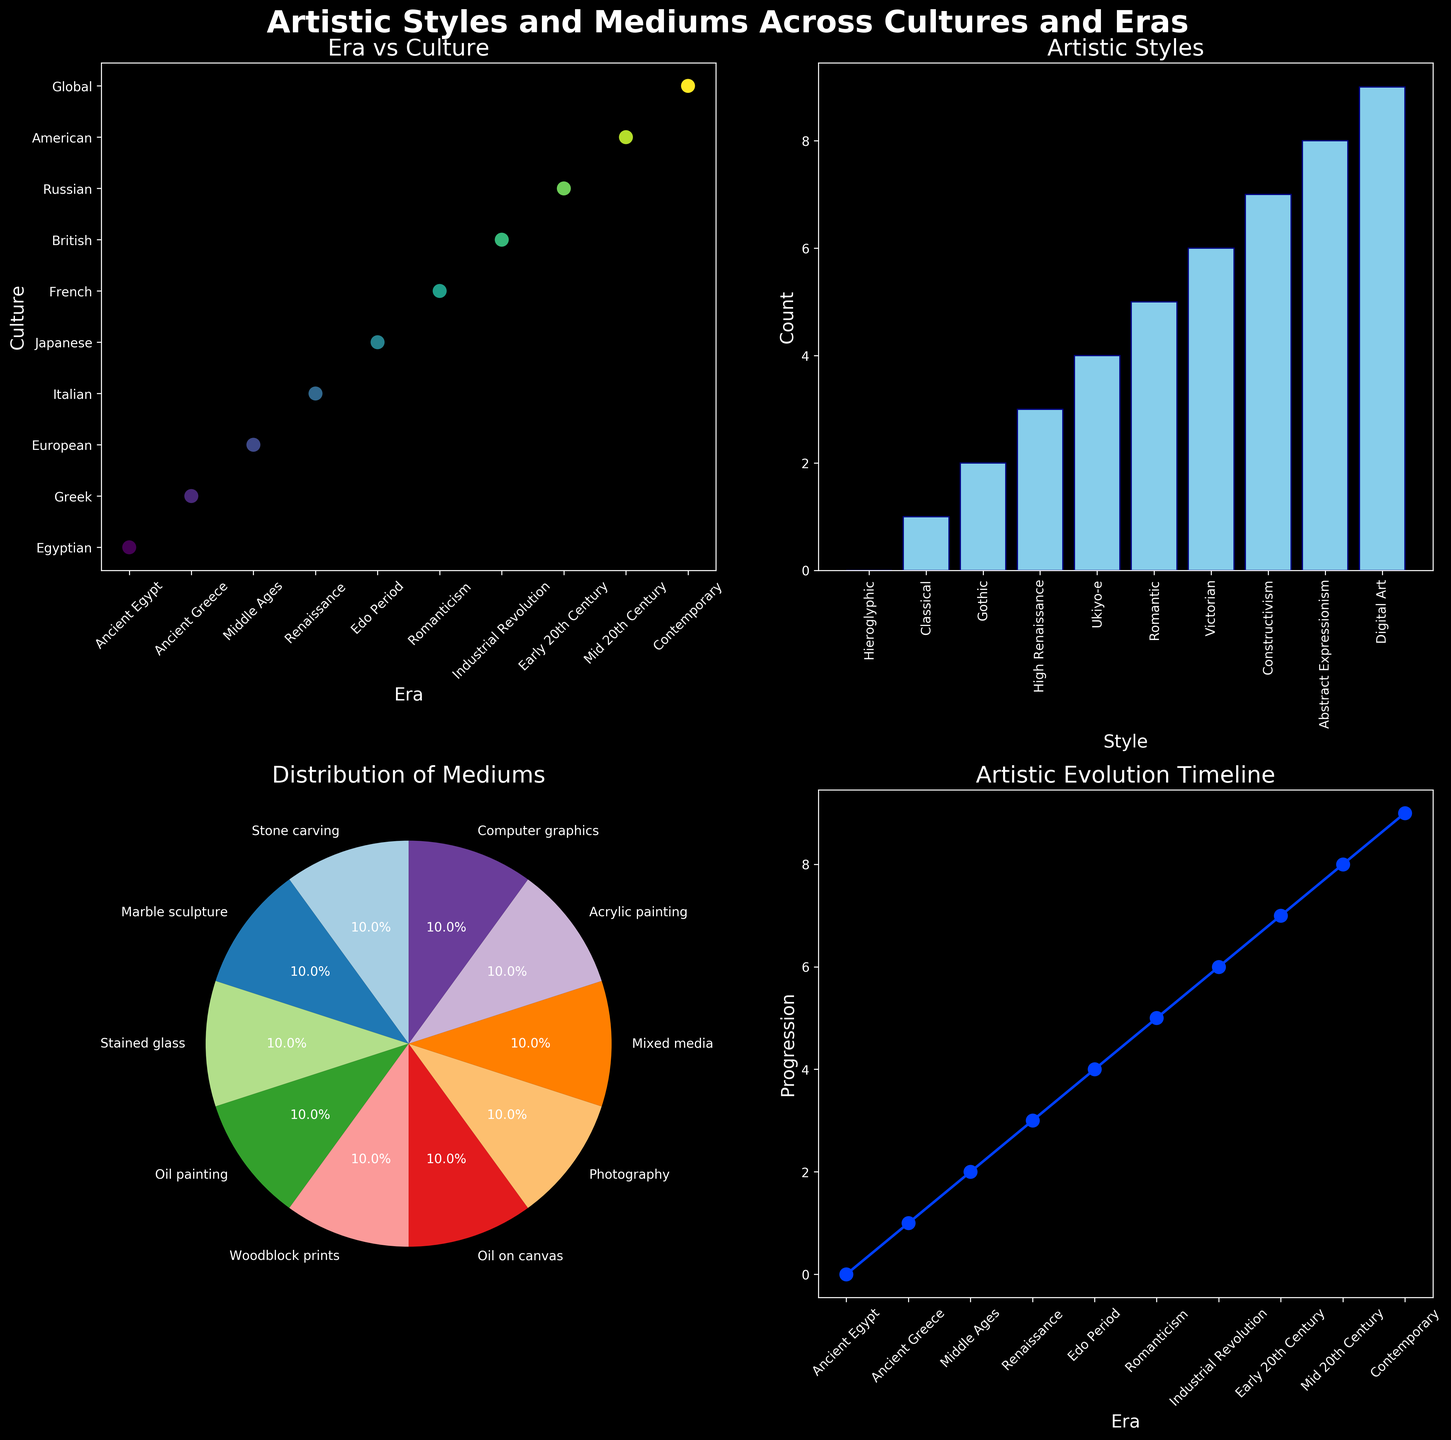What are some examples of artistic styles listed in the figure? Look at the bar chart labeled "Artistic Styles" in the top right subplot. Each bar represents a different artistic style. Some examples are Classical, Gothic, and Ukiyo-e.
Answer: Classical, Gothic, Ukiyo-e How many cultures are represented in the "Era vs Culture" scatter plot? Refer to the scatter plot on the top left labeled "Era vs Culture". Each data point represents a different culture. Count the number of distinct cultures mentioned.
Answer: 10 What percentage of the mediums are 'Oil painting'? Check the pie chart labeled "Distribution of Mediums" in the bottom left subplot. Identify the segment for "Oil painting" and read the percentage directly from the chart.
Answer: 11.1% Which era is associated with the "High Renaissance" artistic style? Refer to the bar chart "Artistic Styles" and find the bar labeled "High Renaissance". This corresponds to the "Renaissance" era.
Answer: Renaissance What is the earliest era mentioned in the "Artistic Evolution Timeline"? Look at the line plot in the bottom right subplot labeled "Artistic Evolution Timeline". Identify the earliest era on the x-axis.
Answer: Ancient Egypt Which artistic style appears to have influenced multiple cultures? Analyze the "Artistic Styles" bar chart to see if any style has multiple cultures connected to it. Since this information can't be inferred directly, investigate the scatter plot for multiple same-colored points corresponding to different cultures if such detail was encoded.
Answer: N/A (Not directly inferable) Between "Victorian" and "Digital Art", which one appears later in the "Artistic Evolution Timeline"? Refer to the timeline plot in the bottom right. The x-axis denotes the eras. Compare the positions of "Victorian" and "Digital Art".
Answer: Digital Art Calculate the ratio of the number of pieces using "Marble sculpture" to those using "Oil painting" as the medium. From the pie chart "Distribution of Mediums", locate the sections for "Marble sculpture" and "Oil painting". Count the segments if they have counts listed, otherwise, a general estimate can be difficult if only percentages are given. Here it's 1:1 from the dataset.
Answer: 1:1 How does the count of "Stone carving" compare to "Photography" in the pie chart? Examine the pie chart "Distribution of Mediums". Identify and compare the sizes or percentages of the sections for "Stone carving" and "Photography".
Answer: Equal (11.1%) 